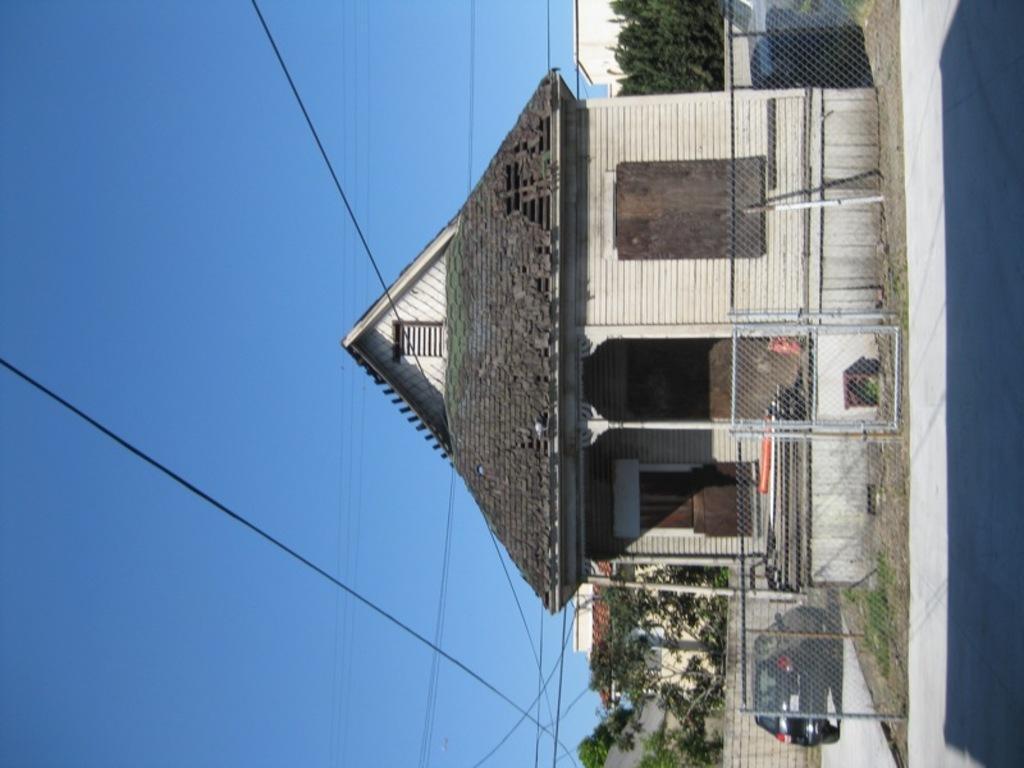Could you give a brief overview of what you see in this image? In this image I can see a house in the middle and beside the house I can see car and tree and in front of the house I can see a fence. I can see power line cables and the sky on the left side 